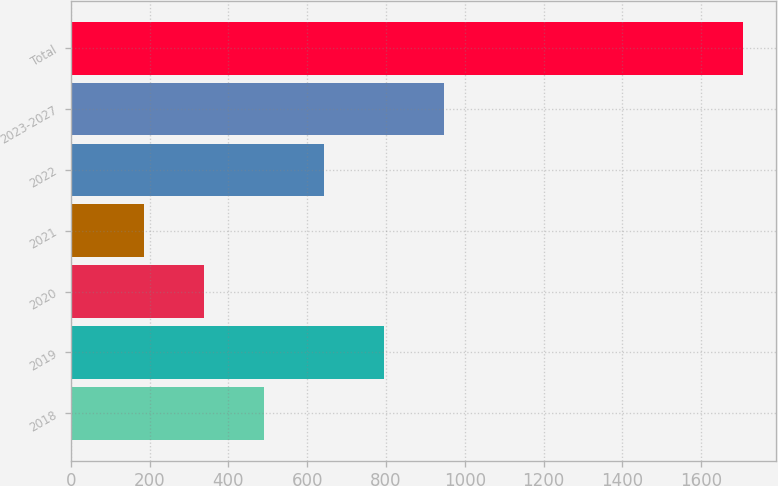<chart> <loc_0><loc_0><loc_500><loc_500><bar_chart><fcel>2018<fcel>2019<fcel>2020<fcel>2021<fcel>2022<fcel>2023-2027<fcel>Total<nl><fcel>490.8<fcel>794.6<fcel>338.9<fcel>187<fcel>642.7<fcel>946.5<fcel>1706<nl></chart> 